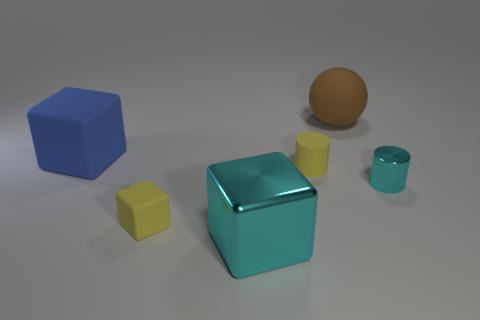Add 2 tiny metal things. How many objects exist? 8 Subtract all balls. How many objects are left? 5 Add 1 small matte objects. How many small matte objects are left? 3 Add 3 small yellow cubes. How many small yellow cubes exist? 4 Subtract 0 yellow spheres. How many objects are left? 6 Subtract all small brown matte blocks. Subtract all large cubes. How many objects are left? 4 